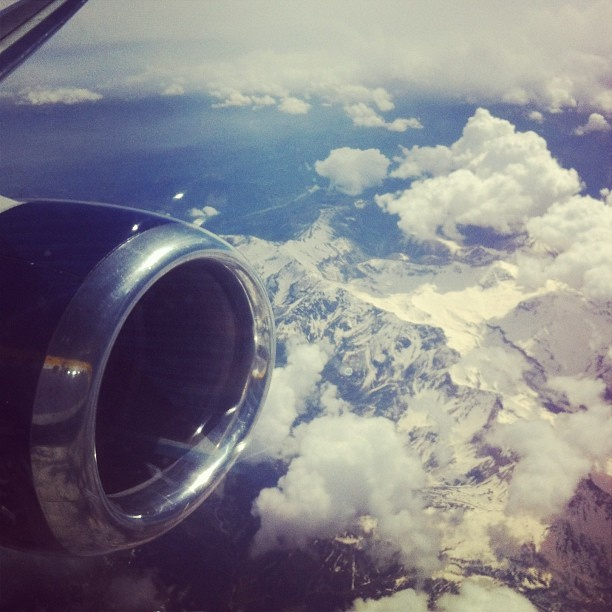Describe the objects in this image and their specific colors. I can see a airplane in gray, black, navy, and purple tones in this image. 